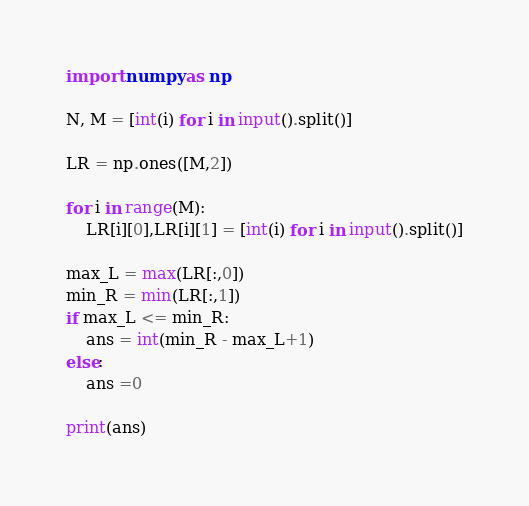Convert code to text. <code><loc_0><loc_0><loc_500><loc_500><_Python_>import numpy as np

N, M = [int(i) for i in input().split()]

LR = np.ones([M,2])

for i in range(M):
    LR[i][0],LR[i][1] = [int(i) for i in input().split()]
    
max_L = max(LR[:,0])
min_R = min(LR[:,1])
if max_L <= min_R:
    ans = int(min_R - max_L+1)
else:
    ans =0
    
print(ans)
</code> 